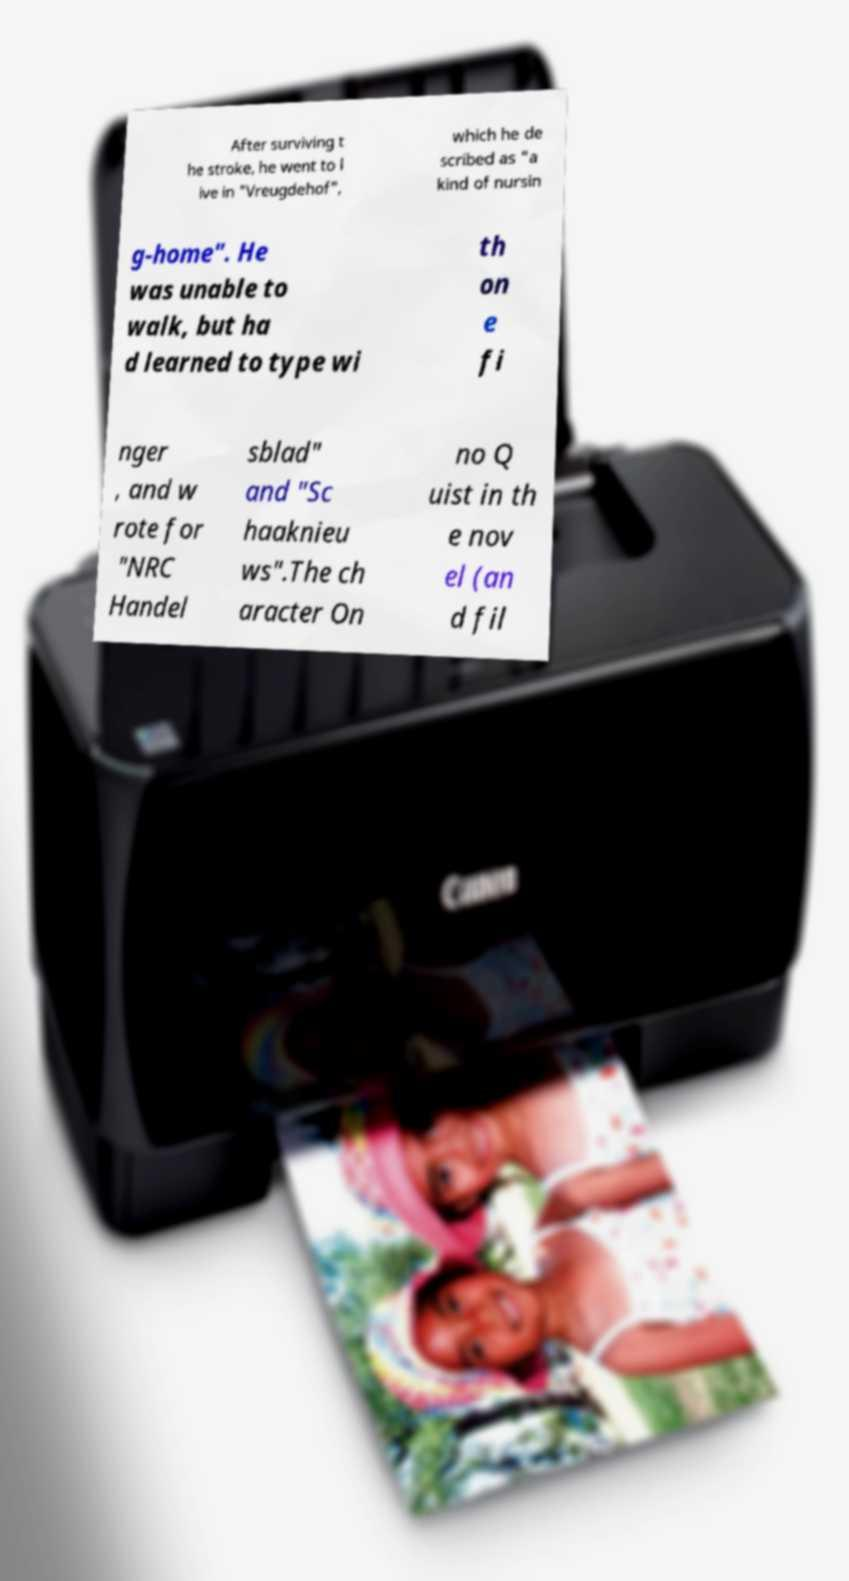I need the written content from this picture converted into text. Can you do that? After surviving t he stroke, he went to l ive in "Vreugdehof", which he de scribed as "a kind of nursin g-home". He was unable to walk, but ha d learned to type wi th on e fi nger , and w rote for "NRC Handel sblad" and "Sc haaknieu ws".The ch aracter On no Q uist in th e nov el (an d fil 